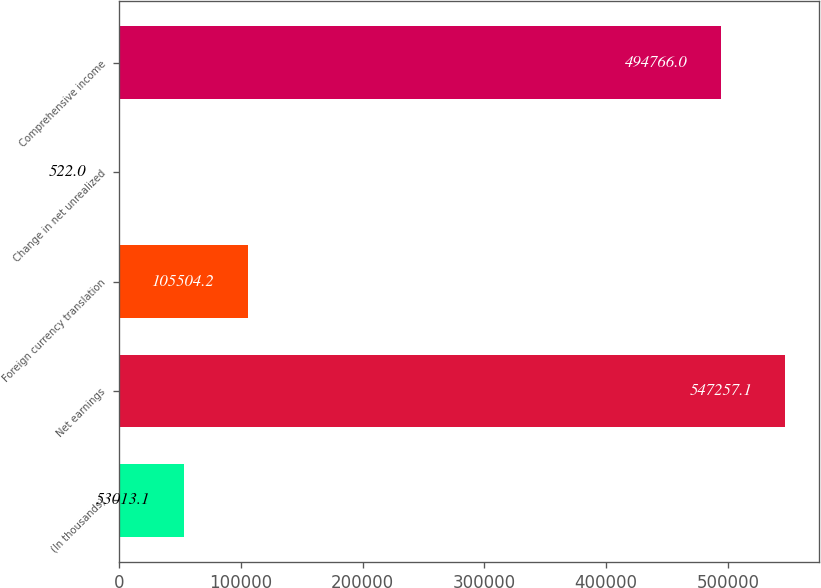Convert chart to OTSL. <chart><loc_0><loc_0><loc_500><loc_500><bar_chart><fcel>(In thousands)<fcel>Net earnings<fcel>Foreign currency translation<fcel>Change in net unrealized<fcel>Comprehensive income<nl><fcel>53013.1<fcel>547257<fcel>105504<fcel>522<fcel>494766<nl></chart> 